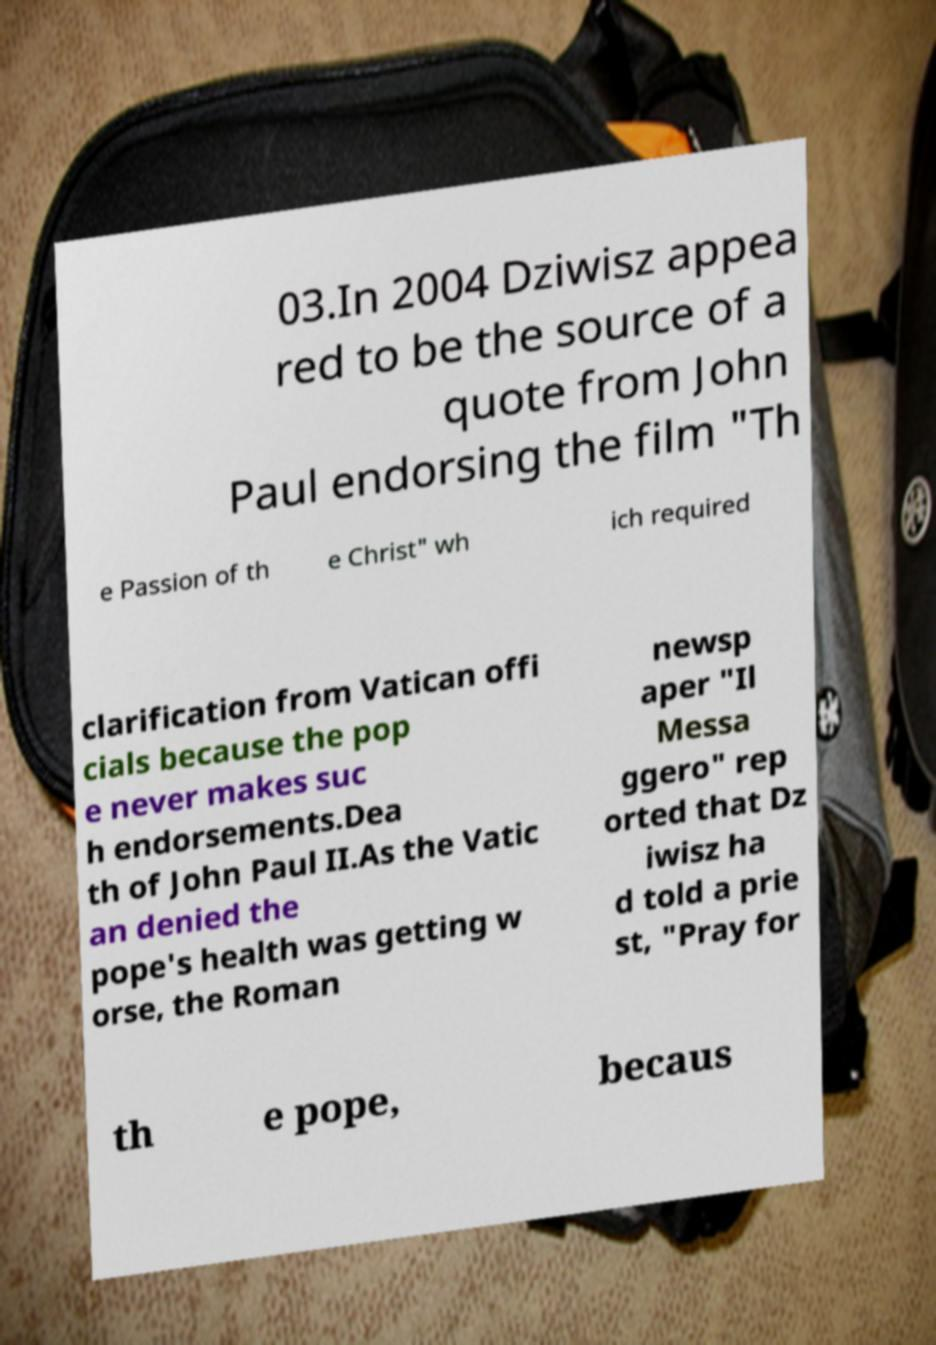For documentation purposes, I need the text within this image transcribed. Could you provide that? 03.In 2004 Dziwisz appea red to be the source of a quote from John Paul endorsing the film "Th e Passion of th e Christ" wh ich required clarification from Vatican offi cials because the pop e never makes suc h endorsements.Dea th of John Paul II.As the Vatic an denied the pope's health was getting w orse, the Roman newsp aper "Il Messa ggero" rep orted that Dz iwisz ha d told a prie st, "Pray for th e pope, becaus 